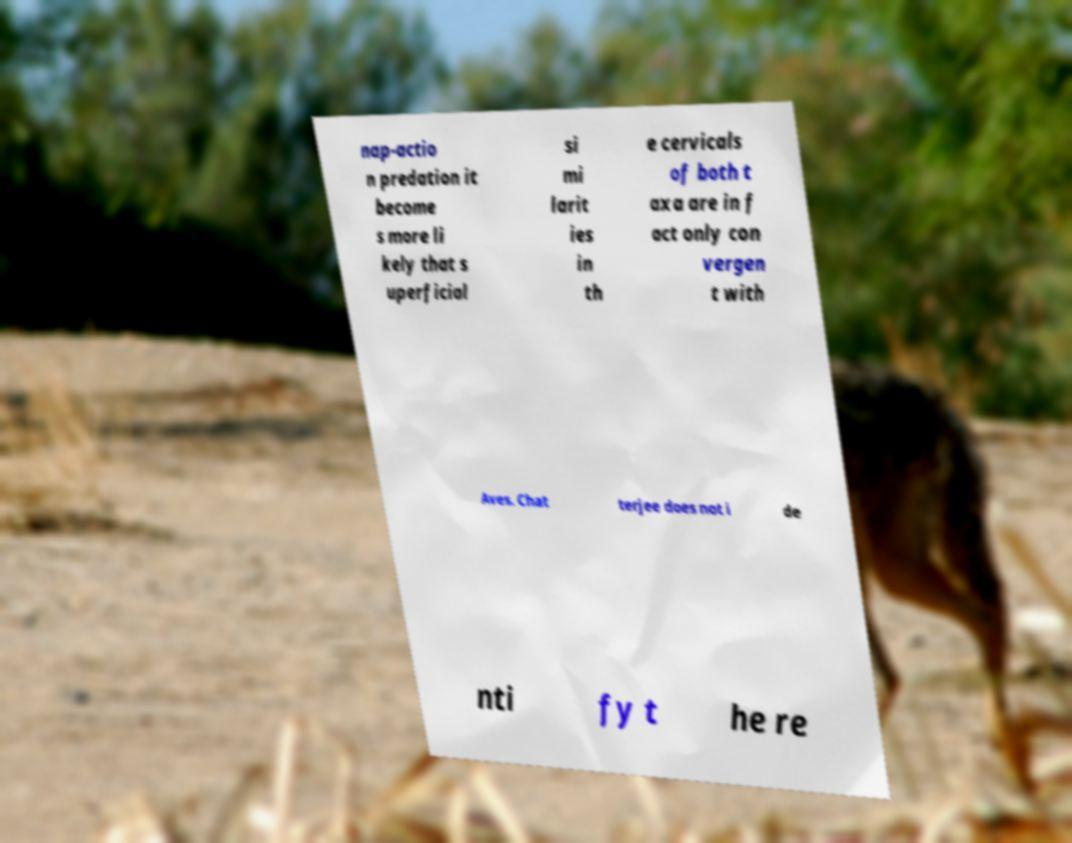Please identify and transcribe the text found in this image. nap-actio n predation it become s more li kely that s uperficial si mi larit ies in th e cervicals of both t axa are in f act only con vergen t with Aves. Chat terjee does not i de nti fy t he re 